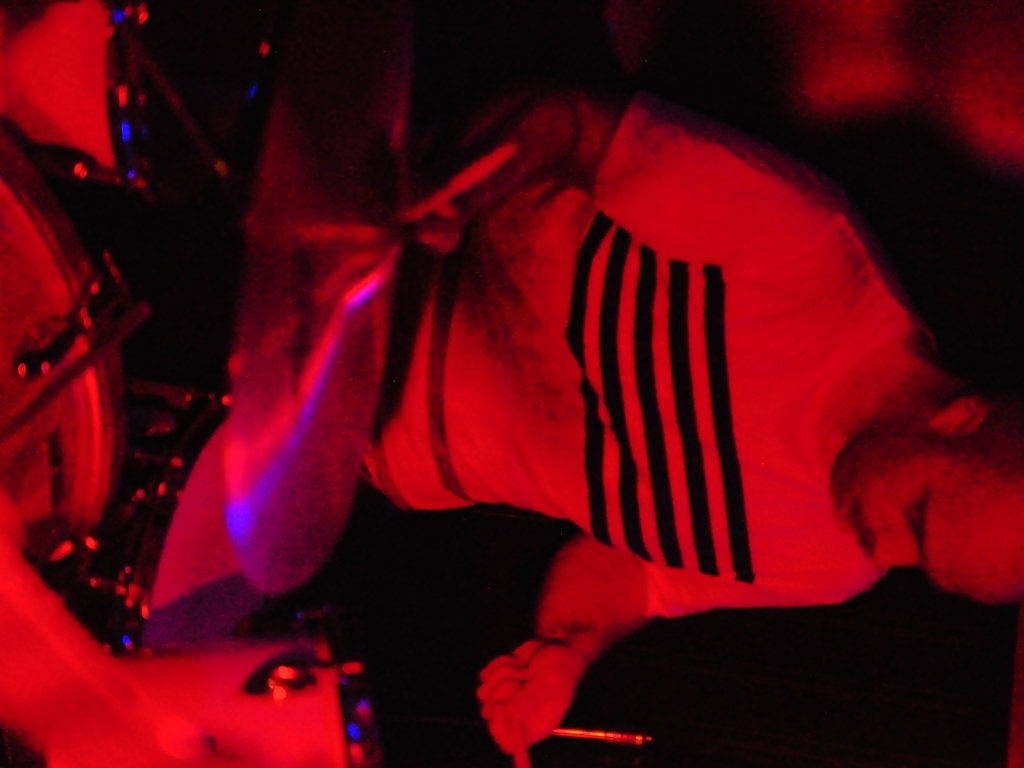Can you describe the lighting of the scene? The scene is bathed in a monochromatic red light, possibly from stage lights, with shadows suggesting a directional light source. This selective and dramatic lighting enhances the motion and mood, focusing attention on the performer. 